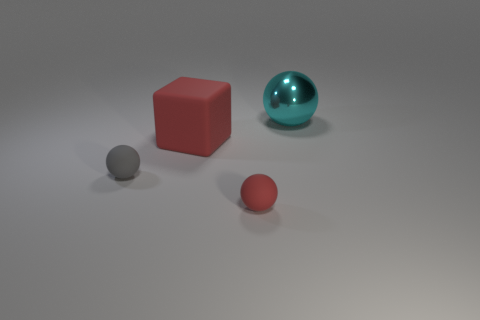What number of other things are there of the same shape as the big red thing?
Keep it short and to the point. 0. There is a small ball in front of the small matte thing on the left side of the large thing that is to the left of the large cyan shiny ball; what is it made of?
Provide a succinct answer. Rubber. Is the number of cyan shiny things that are to the right of the big cyan shiny thing the same as the number of large red blocks?
Offer a terse response. No. Does the large thing that is left of the metal thing have the same material as the tiny object that is on the right side of the big red rubber thing?
Provide a succinct answer. Yes. Is there anything else that has the same material as the large cyan ball?
Keep it short and to the point. No. Is the shape of the big thing that is to the left of the big sphere the same as the small thing that is to the left of the block?
Your answer should be very brief. No. Are there fewer big red blocks that are in front of the red rubber block than small red matte things?
Your answer should be very brief. Yes. What number of rubber balls are the same color as the cube?
Your answer should be compact. 1. There is a rubber ball right of the small gray rubber thing; what size is it?
Keep it short and to the point. Small. There is a tiny rubber thing that is behind the red thing to the right of the big object that is in front of the large metallic thing; what shape is it?
Your answer should be compact. Sphere. 